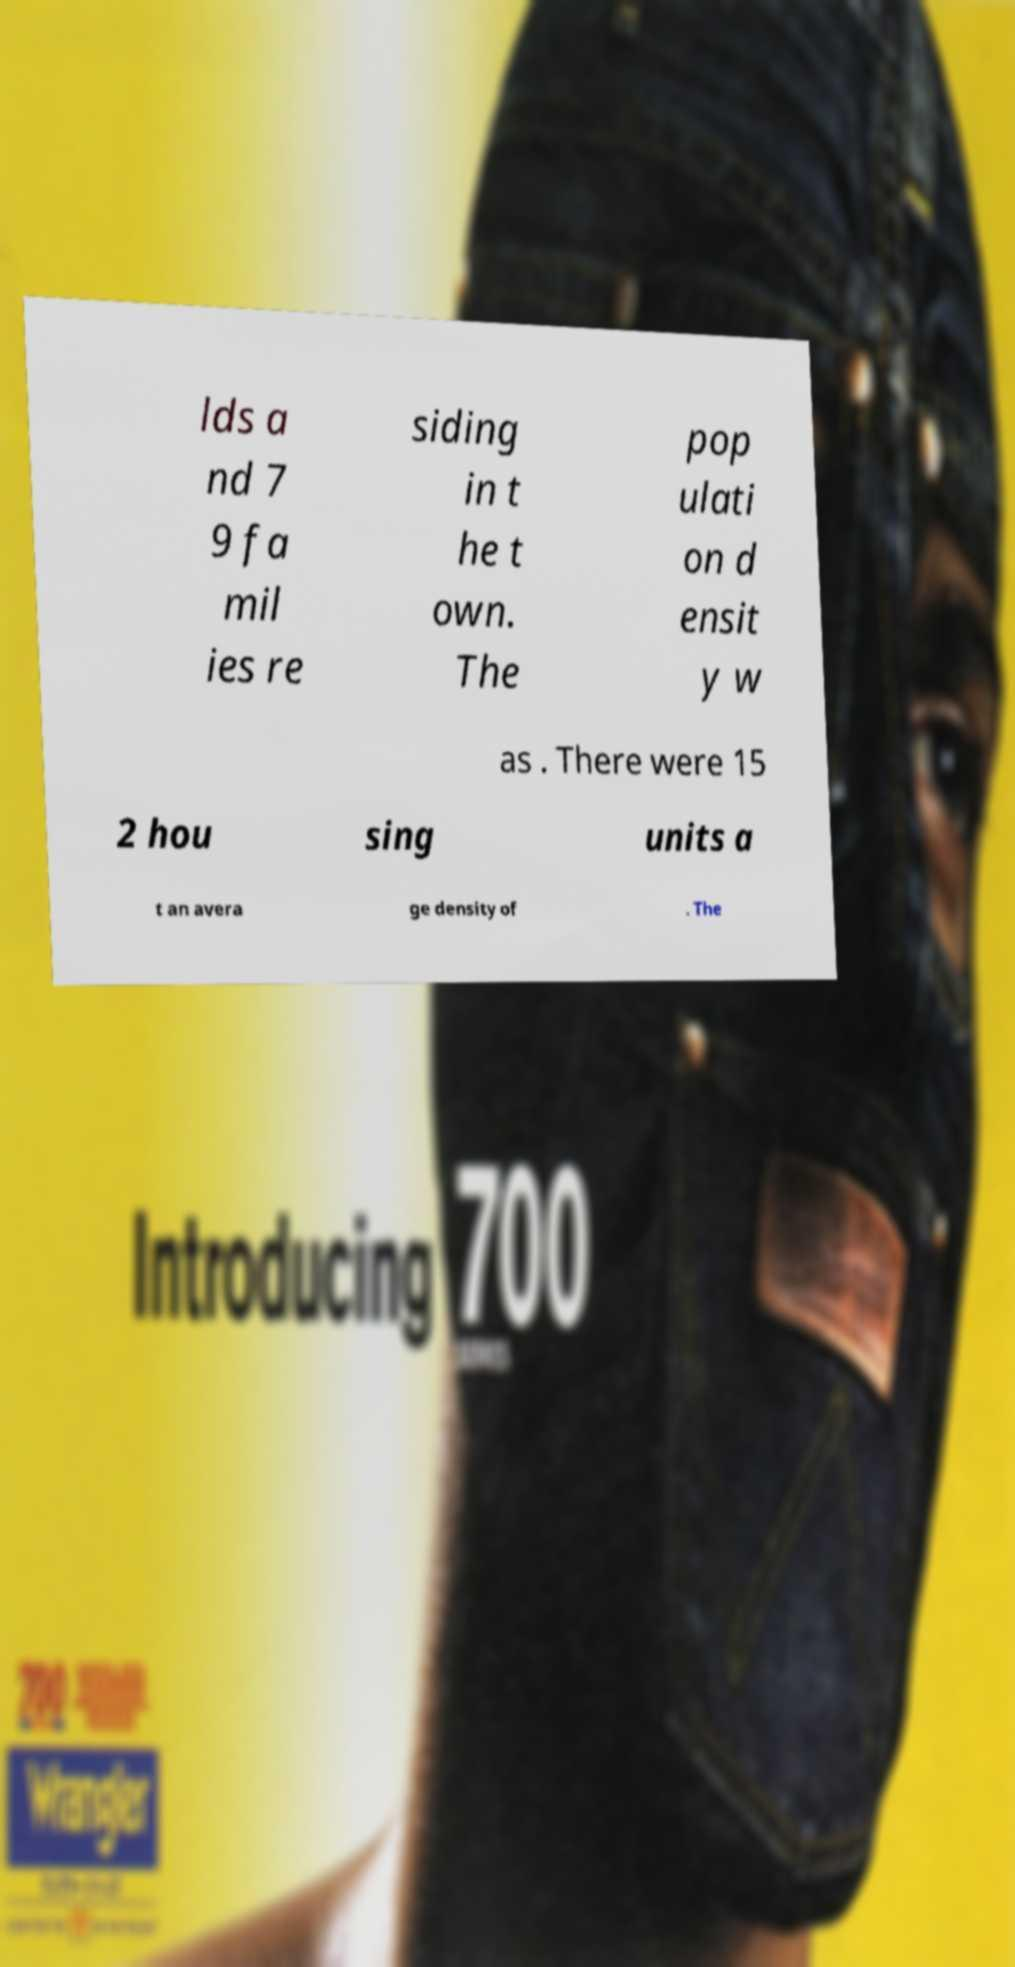Can you accurately transcribe the text from the provided image for me? lds a nd 7 9 fa mil ies re siding in t he t own. The pop ulati on d ensit y w as . There were 15 2 hou sing units a t an avera ge density of . The 